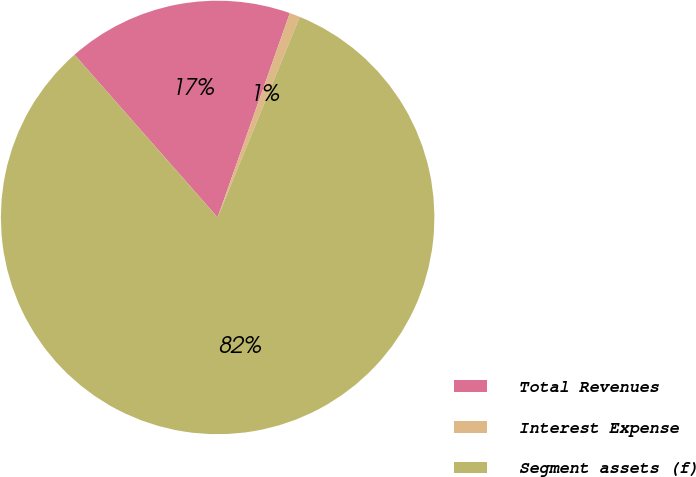Convert chart. <chart><loc_0><loc_0><loc_500><loc_500><pie_chart><fcel>Total Revenues<fcel>Interest Expense<fcel>Segment assets (f)<nl><fcel>16.89%<fcel>0.78%<fcel>82.33%<nl></chart> 